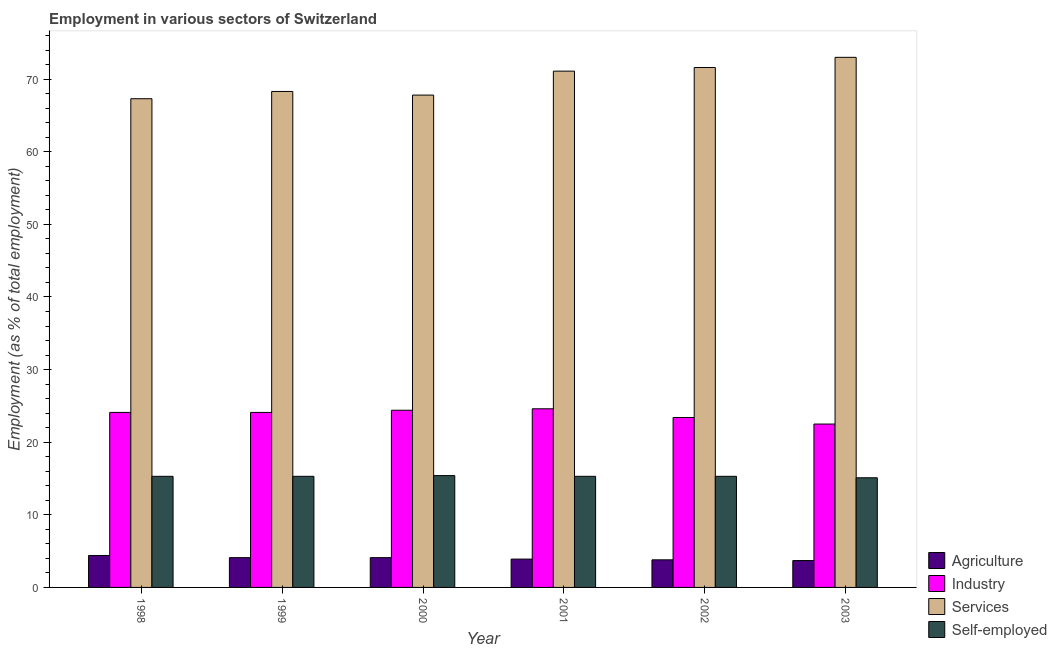How many groups of bars are there?
Your response must be concise. 6. Are the number of bars per tick equal to the number of legend labels?
Offer a very short reply. Yes. How many bars are there on the 1st tick from the left?
Ensure brevity in your answer.  4. How many bars are there on the 3rd tick from the right?
Offer a terse response. 4. What is the label of the 6th group of bars from the left?
Your answer should be compact. 2003. What is the percentage of workers in industry in 2001?
Your answer should be compact. 24.6. Across all years, what is the minimum percentage of self employed workers?
Your answer should be very brief. 15.1. In which year was the percentage of self employed workers maximum?
Your answer should be very brief. 2000. What is the total percentage of self employed workers in the graph?
Provide a succinct answer. 91.7. What is the difference between the percentage of workers in services in 2001 and that in 2003?
Offer a very short reply. -1.9. What is the difference between the percentage of workers in industry in 2003 and the percentage of workers in services in 1999?
Your answer should be compact. -1.6. What is the average percentage of workers in services per year?
Make the answer very short. 69.85. In the year 2002, what is the difference between the percentage of workers in agriculture and percentage of workers in services?
Make the answer very short. 0. Is the percentage of workers in industry in 2001 less than that in 2002?
Keep it short and to the point. No. Is the difference between the percentage of self employed workers in 2002 and 2003 greater than the difference between the percentage of workers in services in 2002 and 2003?
Your response must be concise. No. What is the difference between the highest and the second highest percentage of workers in industry?
Your answer should be very brief. 0.2. What is the difference between the highest and the lowest percentage of workers in agriculture?
Make the answer very short. 0.7. In how many years, is the percentage of workers in services greater than the average percentage of workers in services taken over all years?
Your answer should be very brief. 3. Is it the case that in every year, the sum of the percentage of self employed workers and percentage of workers in services is greater than the sum of percentage of workers in industry and percentage of workers in agriculture?
Make the answer very short. No. What does the 4th bar from the left in 2000 represents?
Your answer should be compact. Self-employed. What does the 2nd bar from the right in 2000 represents?
Offer a very short reply. Services. Is it the case that in every year, the sum of the percentage of workers in agriculture and percentage of workers in industry is greater than the percentage of workers in services?
Your answer should be very brief. No. How many years are there in the graph?
Make the answer very short. 6. What is the difference between two consecutive major ticks on the Y-axis?
Provide a short and direct response. 10. Where does the legend appear in the graph?
Provide a succinct answer. Bottom right. How many legend labels are there?
Offer a very short reply. 4. What is the title of the graph?
Keep it short and to the point. Employment in various sectors of Switzerland. Does "Social equity" appear as one of the legend labels in the graph?
Make the answer very short. No. What is the label or title of the X-axis?
Ensure brevity in your answer.  Year. What is the label or title of the Y-axis?
Your response must be concise. Employment (as % of total employment). What is the Employment (as % of total employment) in Agriculture in 1998?
Your response must be concise. 4.4. What is the Employment (as % of total employment) in Industry in 1998?
Keep it short and to the point. 24.1. What is the Employment (as % of total employment) in Services in 1998?
Provide a succinct answer. 67.3. What is the Employment (as % of total employment) of Self-employed in 1998?
Your answer should be compact. 15.3. What is the Employment (as % of total employment) in Agriculture in 1999?
Your answer should be very brief. 4.1. What is the Employment (as % of total employment) of Industry in 1999?
Give a very brief answer. 24.1. What is the Employment (as % of total employment) of Services in 1999?
Keep it short and to the point. 68.3. What is the Employment (as % of total employment) in Self-employed in 1999?
Keep it short and to the point. 15.3. What is the Employment (as % of total employment) of Agriculture in 2000?
Your answer should be compact. 4.1. What is the Employment (as % of total employment) of Industry in 2000?
Give a very brief answer. 24.4. What is the Employment (as % of total employment) in Services in 2000?
Offer a very short reply. 67.8. What is the Employment (as % of total employment) in Self-employed in 2000?
Ensure brevity in your answer.  15.4. What is the Employment (as % of total employment) in Agriculture in 2001?
Provide a succinct answer. 3.9. What is the Employment (as % of total employment) in Industry in 2001?
Make the answer very short. 24.6. What is the Employment (as % of total employment) of Services in 2001?
Provide a succinct answer. 71.1. What is the Employment (as % of total employment) in Self-employed in 2001?
Provide a succinct answer. 15.3. What is the Employment (as % of total employment) in Agriculture in 2002?
Offer a terse response. 3.8. What is the Employment (as % of total employment) of Industry in 2002?
Offer a very short reply. 23.4. What is the Employment (as % of total employment) in Services in 2002?
Your answer should be compact. 71.6. What is the Employment (as % of total employment) in Self-employed in 2002?
Your answer should be very brief. 15.3. What is the Employment (as % of total employment) of Agriculture in 2003?
Offer a very short reply. 3.7. What is the Employment (as % of total employment) in Services in 2003?
Offer a very short reply. 73. What is the Employment (as % of total employment) of Self-employed in 2003?
Provide a short and direct response. 15.1. Across all years, what is the maximum Employment (as % of total employment) of Agriculture?
Make the answer very short. 4.4. Across all years, what is the maximum Employment (as % of total employment) in Industry?
Provide a short and direct response. 24.6. Across all years, what is the maximum Employment (as % of total employment) in Self-employed?
Your response must be concise. 15.4. Across all years, what is the minimum Employment (as % of total employment) in Agriculture?
Offer a very short reply. 3.7. Across all years, what is the minimum Employment (as % of total employment) of Services?
Provide a succinct answer. 67.3. Across all years, what is the minimum Employment (as % of total employment) of Self-employed?
Your answer should be compact. 15.1. What is the total Employment (as % of total employment) of Agriculture in the graph?
Give a very brief answer. 24. What is the total Employment (as % of total employment) in Industry in the graph?
Your answer should be very brief. 143.1. What is the total Employment (as % of total employment) of Services in the graph?
Your answer should be compact. 419.1. What is the total Employment (as % of total employment) of Self-employed in the graph?
Provide a short and direct response. 91.7. What is the difference between the Employment (as % of total employment) of Industry in 1998 and that in 1999?
Ensure brevity in your answer.  0. What is the difference between the Employment (as % of total employment) of Services in 1998 and that in 1999?
Your answer should be compact. -1. What is the difference between the Employment (as % of total employment) of Self-employed in 1998 and that in 1999?
Your answer should be very brief. 0. What is the difference between the Employment (as % of total employment) in Services in 1998 and that in 2000?
Ensure brevity in your answer.  -0.5. What is the difference between the Employment (as % of total employment) of Agriculture in 1998 and that in 2001?
Your answer should be compact. 0.5. What is the difference between the Employment (as % of total employment) in Industry in 1998 and that in 2001?
Provide a succinct answer. -0.5. What is the difference between the Employment (as % of total employment) in Services in 1998 and that in 2001?
Your answer should be compact. -3.8. What is the difference between the Employment (as % of total employment) of Agriculture in 1998 and that in 2002?
Provide a short and direct response. 0.6. What is the difference between the Employment (as % of total employment) of Agriculture in 1998 and that in 2003?
Keep it short and to the point. 0.7. What is the difference between the Employment (as % of total employment) in Services in 1998 and that in 2003?
Offer a terse response. -5.7. What is the difference between the Employment (as % of total employment) of Self-employed in 1998 and that in 2003?
Your answer should be compact. 0.2. What is the difference between the Employment (as % of total employment) of Industry in 1999 and that in 2000?
Ensure brevity in your answer.  -0.3. What is the difference between the Employment (as % of total employment) in Services in 1999 and that in 2000?
Offer a terse response. 0.5. What is the difference between the Employment (as % of total employment) in Self-employed in 1999 and that in 2000?
Provide a succinct answer. -0.1. What is the difference between the Employment (as % of total employment) in Agriculture in 1999 and that in 2001?
Provide a succinct answer. 0.2. What is the difference between the Employment (as % of total employment) in Services in 1999 and that in 2001?
Offer a very short reply. -2.8. What is the difference between the Employment (as % of total employment) of Industry in 1999 and that in 2003?
Offer a very short reply. 1.6. What is the difference between the Employment (as % of total employment) in Services in 1999 and that in 2003?
Provide a succinct answer. -4.7. What is the difference between the Employment (as % of total employment) in Services in 2000 and that in 2001?
Keep it short and to the point. -3.3. What is the difference between the Employment (as % of total employment) in Agriculture in 2000 and that in 2002?
Offer a terse response. 0.3. What is the difference between the Employment (as % of total employment) of Self-employed in 2000 and that in 2002?
Your answer should be compact. 0.1. What is the difference between the Employment (as % of total employment) in Agriculture in 2000 and that in 2003?
Provide a short and direct response. 0.4. What is the difference between the Employment (as % of total employment) of Industry in 2000 and that in 2003?
Ensure brevity in your answer.  1.9. What is the difference between the Employment (as % of total employment) of Services in 2000 and that in 2003?
Your answer should be compact. -5.2. What is the difference between the Employment (as % of total employment) in Services in 2001 and that in 2002?
Give a very brief answer. -0.5. What is the difference between the Employment (as % of total employment) in Agriculture in 2001 and that in 2003?
Provide a succinct answer. 0.2. What is the difference between the Employment (as % of total employment) of Industry in 2001 and that in 2003?
Your answer should be compact. 2.1. What is the difference between the Employment (as % of total employment) of Services in 2001 and that in 2003?
Provide a succinct answer. -1.9. What is the difference between the Employment (as % of total employment) of Self-employed in 2001 and that in 2003?
Keep it short and to the point. 0.2. What is the difference between the Employment (as % of total employment) in Agriculture in 2002 and that in 2003?
Ensure brevity in your answer.  0.1. What is the difference between the Employment (as % of total employment) of Industry in 2002 and that in 2003?
Provide a short and direct response. 0.9. What is the difference between the Employment (as % of total employment) in Services in 2002 and that in 2003?
Keep it short and to the point. -1.4. What is the difference between the Employment (as % of total employment) in Self-employed in 2002 and that in 2003?
Offer a terse response. 0.2. What is the difference between the Employment (as % of total employment) of Agriculture in 1998 and the Employment (as % of total employment) of Industry in 1999?
Offer a very short reply. -19.7. What is the difference between the Employment (as % of total employment) in Agriculture in 1998 and the Employment (as % of total employment) in Services in 1999?
Provide a succinct answer. -63.9. What is the difference between the Employment (as % of total employment) in Agriculture in 1998 and the Employment (as % of total employment) in Self-employed in 1999?
Provide a succinct answer. -10.9. What is the difference between the Employment (as % of total employment) in Industry in 1998 and the Employment (as % of total employment) in Services in 1999?
Your response must be concise. -44.2. What is the difference between the Employment (as % of total employment) of Industry in 1998 and the Employment (as % of total employment) of Self-employed in 1999?
Your answer should be compact. 8.8. What is the difference between the Employment (as % of total employment) of Agriculture in 1998 and the Employment (as % of total employment) of Services in 2000?
Offer a terse response. -63.4. What is the difference between the Employment (as % of total employment) of Agriculture in 1998 and the Employment (as % of total employment) of Self-employed in 2000?
Provide a succinct answer. -11. What is the difference between the Employment (as % of total employment) in Industry in 1998 and the Employment (as % of total employment) in Services in 2000?
Provide a short and direct response. -43.7. What is the difference between the Employment (as % of total employment) in Industry in 1998 and the Employment (as % of total employment) in Self-employed in 2000?
Make the answer very short. 8.7. What is the difference between the Employment (as % of total employment) in Services in 1998 and the Employment (as % of total employment) in Self-employed in 2000?
Provide a short and direct response. 51.9. What is the difference between the Employment (as % of total employment) in Agriculture in 1998 and the Employment (as % of total employment) in Industry in 2001?
Provide a succinct answer. -20.2. What is the difference between the Employment (as % of total employment) in Agriculture in 1998 and the Employment (as % of total employment) in Services in 2001?
Provide a short and direct response. -66.7. What is the difference between the Employment (as % of total employment) in Industry in 1998 and the Employment (as % of total employment) in Services in 2001?
Offer a terse response. -47. What is the difference between the Employment (as % of total employment) of Industry in 1998 and the Employment (as % of total employment) of Self-employed in 2001?
Your answer should be very brief. 8.8. What is the difference between the Employment (as % of total employment) in Services in 1998 and the Employment (as % of total employment) in Self-employed in 2001?
Give a very brief answer. 52. What is the difference between the Employment (as % of total employment) of Agriculture in 1998 and the Employment (as % of total employment) of Industry in 2002?
Ensure brevity in your answer.  -19. What is the difference between the Employment (as % of total employment) in Agriculture in 1998 and the Employment (as % of total employment) in Services in 2002?
Offer a very short reply. -67.2. What is the difference between the Employment (as % of total employment) of Agriculture in 1998 and the Employment (as % of total employment) of Self-employed in 2002?
Offer a terse response. -10.9. What is the difference between the Employment (as % of total employment) in Industry in 1998 and the Employment (as % of total employment) in Services in 2002?
Provide a short and direct response. -47.5. What is the difference between the Employment (as % of total employment) in Agriculture in 1998 and the Employment (as % of total employment) in Industry in 2003?
Give a very brief answer. -18.1. What is the difference between the Employment (as % of total employment) of Agriculture in 1998 and the Employment (as % of total employment) of Services in 2003?
Offer a terse response. -68.6. What is the difference between the Employment (as % of total employment) of Agriculture in 1998 and the Employment (as % of total employment) of Self-employed in 2003?
Keep it short and to the point. -10.7. What is the difference between the Employment (as % of total employment) in Industry in 1998 and the Employment (as % of total employment) in Services in 2003?
Ensure brevity in your answer.  -48.9. What is the difference between the Employment (as % of total employment) of Services in 1998 and the Employment (as % of total employment) of Self-employed in 2003?
Provide a short and direct response. 52.2. What is the difference between the Employment (as % of total employment) in Agriculture in 1999 and the Employment (as % of total employment) in Industry in 2000?
Provide a succinct answer. -20.3. What is the difference between the Employment (as % of total employment) in Agriculture in 1999 and the Employment (as % of total employment) in Services in 2000?
Give a very brief answer. -63.7. What is the difference between the Employment (as % of total employment) of Industry in 1999 and the Employment (as % of total employment) of Services in 2000?
Keep it short and to the point. -43.7. What is the difference between the Employment (as % of total employment) of Services in 1999 and the Employment (as % of total employment) of Self-employed in 2000?
Your answer should be very brief. 52.9. What is the difference between the Employment (as % of total employment) of Agriculture in 1999 and the Employment (as % of total employment) of Industry in 2001?
Your response must be concise. -20.5. What is the difference between the Employment (as % of total employment) in Agriculture in 1999 and the Employment (as % of total employment) in Services in 2001?
Offer a very short reply. -67. What is the difference between the Employment (as % of total employment) of Industry in 1999 and the Employment (as % of total employment) of Services in 2001?
Ensure brevity in your answer.  -47. What is the difference between the Employment (as % of total employment) in Services in 1999 and the Employment (as % of total employment) in Self-employed in 2001?
Your answer should be very brief. 53. What is the difference between the Employment (as % of total employment) in Agriculture in 1999 and the Employment (as % of total employment) in Industry in 2002?
Offer a terse response. -19.3. What is the difference between the Employment (as % of total employment) of Agriculture in 1999 and the Employment (as % of total employment) of Services in 2002?
Make the answer very short. -67.5. What is the difference between the Employment (as % of total employment) in Agriculture in 1999 and the Employment (as % of total employment) in Self-employed in 2002?
Offer a very short reply. -11.2. What is the difference between the Employment (as % of total employment) of Industry in 1999 and the Employment (as % of total employment) of Services in 2002?
Provide a short and direct response. -47.5. What is the difference between the Employment (as % of total employment) of Industry in 1999 and the Employment (as % of total employment) of Self-employed in 2002?
Give a very brief answer. 8.8. What is the difference between the Employment (as % of total employment) in Agriculture in 1999 and the Employment (as % of total employment) in Industry in 2003?
Your response must be concise. -18.4. What is the difference between the Employment (as % of total employment) of Agriculture in 1999 and the Employment (as % of total employment) of Services in 2003?
Provide a short and direct response. -68.9. What is the difference between the Employment (as % of total employment) of Agriculture in 1999 and the Employment (as % of total employment) of Self-employed in 2003?
Offer a terse response. -11. What is the difference between the Employment (as % of total employment) in Industry in 1999 and the Employment (as % of total employment) in Services in 2003?
Give a very brief answer. -48.9. What is the difference between the Employment (as % of total employment) of Services in 1999 and the Employment (as % of total employment) of Self-employed in 2003?
Keep it short and to the point. 53.2. What is the difference between the Employment (as % of total employment) in Agriculture in 2000 and the Employment (as % of total employment) in Industry in 2001?
Your answer should be compact. -20.5. What is the difference between the Employment (as % of total employment) of Agriculture in 2000 and the Employment (as % of total employment) of Services in 2001?
Keep it short and to the point. -67. What is the difference between the Employment (as % of total employment) of Agriculture in 2000 and the Employment (as % of total employment) of Self-employed in 2001?
Provide a succinct answer. -11.2. What is the difference between the Employment (as % of total employment) of Industry in 2000 and the Employment (as % of total employment) of Services in 2001?
Make the answer very short. -46.7. What is the difference between the Employment (as % of total employment) in Industry in 2000 and the Employment (as % of total employment) in Self-employed in 2001?
Offer a very short reply. 9.1. What is the difference between the Employment (as % of total employment) in Services in 2000 and the Employment (as % of total employment) in Self-employed in 2001?
Your answer should be very brief. 52.5. What is the difference between the Employment (as % of total employment) in Agriculture in 2000 and the Employment (as % of total employment) in Industry in 2002?
Keep it short and to the point. -19.3. What is the difference between the Employment (as % of total employment) in Agriculture in 2000 and the Employment (as % of total employment) in Services in 2002?
Give a very brief answer. -67.5. What is the difference between the Employment (as % of total employment) in Agriculture in 2000 and the Employment (as % of total employment) in Self-employed in 2002?
Offer a very short reply. -11.2. What is the difference between the Employment (as % of total employment) of Industry in 2000 and the Employment (as % of total employment) of Services in 2002?
Provide a short and direct response. -47.2. What is the difference between the Employment (as % of total employment) of Services in 2000 and the Employment (as % of total employment) of Self-employed in 2002?
Make the answer very short. 52.5. What is the difference between the Employment (as % of total employment) of Agriculture in 2000 and the Employment (as % of total employment) of Industry in 2003?
Provide a short and direct response. -18.4. What is the difference between the Employment (as % of total employment) of Agriculture in 2000 and the Employment (as % of total employment) of Services in 2003?
Your answer should be very brief. -68.9. What is the difference between the Employment (as % of total employment) in Industry in 2000 and the Employment (as % of total employment) in Services in 2003?
Your answer should be compact. -48.6. What is the difference between the Employment (as % of total employment) in Services in 2000 and the Employment (as % of total employment) in Self-employed in 2003?
Offer a very short reply. 52.7. What is the difference between the Employment (as % of total employment) of Agriculture in 2001 and the Employment (as % of total employment) of Industry in 2002?
Offer a terse response. -19.5. What is the difference between the Employment (as % of total employment) in Agriculture in 2001 and the Employment (as % of total employment) in Services in 2002?
Make the answer very short. -67.7. What is the difference between the Employment (as % of total employment) of Industry in 2001 and the Employment (as % of total employment) of Services in 2002?
Ensure brevity in your answer.  -47. What is the difference between the Employment (as % of total employment) in Services in 2001 and the Employment (as % of total employment) in Self-employed in 2002?
Make the answer very short. 55.8. What is the difference between the Employment (as % of total employment) of Agriculture in 2001 and the Employment (as % of total employment) of Industry in 2003?
Your answer should be very brief. -18.6. What is the difference between the Employment (as % of total employment) of Agriculture in 2001 and the Employment (as % of total employment) of Services in 2003?
Provide a succinct answer. -69.1. What is the difference between the Employment (as % of total employment) in Agriculture in 2001 and the Employment (as % of total employment) in Self-employed in 2003?
Give a very brief answer. -11.2. What is the difference between the Employment (as % of total employment) in Industry in 2001 and the Employment (as % of total employment) in Services in 2003?
Your answer should be compact. -48.4. What is the difference between the Employment (as % of total employment) in Services in 2001 and the Employment (as % of total employment) in Self-employed in 2003?
Provide a succinct answer. 56. What is the difference between the Employment (as % of total employment) of Agriculture in 2002 and the Employment (as % of total employment) of Industry in 2003?
Ensure brevity in your answer.  -18.7. What is the difference between the Employment (as % of total employment) in Agriculture in 2002 and the Employment (as % of total employment) in Services in 2003?
Offer a terse response. -69.2. What is the difference between the Employment (as % of total employment) of Industry in 2002 and the Employment (as % of total employment) of Services in 2003?
Offer a very short reply. -49.6. What is the difference between the Employment (as % of total employment) in Services in 2002 and the Employment (as % of total employment) in Self-employed in 2003?
Provide a short and direct response. 56.5. What is the average Employment (as % of total employment) in Agriculture per year?
Keep it short and to the point. 4. What is the average Employment (as % of total employment) of Industry per year?
Your response must be concise. 23.85. What is the average Employment (as % of total employment) in Services per year?
Ensure brevity in your answer.  69.85. What is the average Employment (as % of total employment) in Self-employed per year?
Make the answer very short. 15.28. In the year 1998, what is the difference between the Employment (as % of total employment) in Agriculture and Employment (as % of total employment) in Industry?
Your answer should be compact. -19.7. In the year 1998, what is the difference between the Employment (as % of total employment) of Agriculture and Employment (as % of total employment) of Services?
Your answer should be compact. -62.9. In the year 1998, what is the difference between the Employment (as % of total employment) in Industry and Employment (as % of total employment) in Services?
Provide a short and direct response. -43.2. In the year 1998, what is the difference between the Employment (as % of total employment) in Services and Employment (as % of total employment) in Self-employed?
Provide a succinct answer. 52. In the year 1999, what is the difference between the Employment (as % of total employment) of Agriculture and Employment (as % of total employment) of Services?
Your response must be concise. -64.2. In the year 1999, what is the difference between the Employment (as % of total employment) in Agriculture and Employment (as % of total employment) in Self-employed?
Ensure brevity in your answer.  -11.2. In the year 1999, what is the difference between the Employment (as % of total employment) in Industry and Employment (as % of total employment) in Services?
Provide a short and direct response. -44.2. In the year 1999, what is the difference between the Employment (as % of total employment) of Services and Employment (as % of total employment) of Self-employed?
Make the answer very short. 53. In the year 2000, what is the difference between the Employment (as % of total employment) in Agriculture and Employment (as % of total employment) in Industry?
Provide a succinct answer. -20.3. In the year 2000, what is the difference between the Employment (as % of total employment) in Agriculture and Employment (as % of total employment) in Services?
Provide a succinct answer. -63.7. In the year 2000, what is the difference between the Employment (as % of total employment) of Industry and Employment (as % of total employment) of Services?
Provide a short and direct response. -43.4. In the year 2000, what is the difference between the Employment (as % of total employment) in Services and Employment (as % of total employment) in Self-employed?
Your response must be concise. 52.4. In the year 2001, what is the difference between the Employment (as % of total employment) of Agriculture and Employment (as % of total employment) of Industry?
Ensure brevity in your answer.  -20.7. In the year 2001, what is the difference between the Employment (as % of total employment) in Agriculture and Employment (as % of total employment) in Services?
Provide a short and direct response. -67.2. In the year 2001, what is the difference between the Employment (as % of total employment) in Industry and Employment (as % of total employment) in Services?
Your response must be concise. -46.5. In the year 2001, what is the difference between the Employment (as % of total employment) in Industry and Employment (as % of total employment) in Self-employed?
Your answer should be very brief. 9.3. In the year 2001, what is the difference between the Employment (as % of total employment) of Services and Employment (as % of total employment) of Self-employed?
Keep it short and to the point. 55.8. In the year 2002, what is the difference between the Employment (as % of total employment) of Agriculture and Employment (as % of total employment) of Industry?
Give a very brief answer. -19.6. In the year 2002, what is the difference between the Employment (as % of total employment) in Agriculture and Employment (as % of total employment) in Services?
Make the answer very short. -67.8. In the year 2002, what is the difference between the Employment (as % of total employment) of Agriculture and Employment (as % of total employment) of Self-employed?
Ensure brevity in your answer.  -11.5. In the year 2002, what is the difference between the Employment (as % of total employment) of Industry and Employment (as % of total employment) of Services?
Provide a succinct answer. -48.2. In the year 2002, what is the difference between the Employment (as % of total employment) in Services and Employment (as % of total employment) in Self-employed?
Your response must be concise. 56.3. In the year 2003, what is the difference between the Employment (as % of total employment) of Agriculture and Employment (as % of total employment) of Industry?
Offer a terse response. -18.8. In the year 2003, what is the difference between the Employment (as % of total employment) of Agriculture and Employment (as % of total employment) of Services?
Offer a very short reply. -69.3. In the year 2003, what is the difference between the Employment (as % of total employment) of Industry and Employment (as % of total employment) of Services?
Your answer should be very brief. -50.5. In the year 2003, what is the difference between the Employment (as % of total employment) in Industry and Employment (as % of total employment) in Self-employed?
Your answer should be very brief. 7.4. In the year 2003, what is the difference between the Employment (as % of total employment) in Services and Employment (as % of total employment) in Self-employed?
Provide a succinct answer. 57.9. What is the ratio of the Employment (as % of total employment) in Agriculture in 1998 to that in 1999?
Offer a terse response. 1.07. What is the ratio of the Employment (as % of total employment) in Services in 1998 to that in 1999?
Provide a succinct answer. 0.99. What is the ratio of the Employment (as % of total employment) in Agriculture in 1998 to that in 2000?
Make the answer very short. 1.07. What is the ratio of the Employment (as % of total employment) of Industry in 1998 to that in 2000?
Provide a succinct answer. 0.99. What is the ratio of the Employment (as % of total employment) of Services in 1998 to that in 2000?
Offer a terse response. 0.99. What is the ratio of the Employment (as % of total employment) of Agriculture in 1998 to that in 2001?
Offer a very short reply. 1.13. What is the ratio of the Employment (as % of total employment) of Industry in 1998 to that in 2001?
Your answer should be very brief. 0.98. What is the ratio of the Employment (as % of total employment) of Services in 1998 to that in 2001?
Your answer should be compact. 0.95. What is the ratio of the Employment (as % of total employment) in Agriculture in 1998 to that in 2002?
Keep it short and to the point. 1.16. What is the ratio of the Employment (as % of total employment) in Industry in 1998 to that in 2002?
Your answer should be very brief. 1.03. What is the ratio of the Employment (as % of total employment) of Services in 1998 to that in 2002?
Ensure brevity in your answer.  0.94. What is the ratio of the Employment (as % of total employment) of Self-employed in 1998 to that in 2002?
Provide a succinct answer. 1. What is the ratio of the Employment (as % of total employment) in Agriculture in 1998 to that in 2003?
Offer a very short reply. 1.19. What is the ratio of the Employment (as % of total employment) of Industry in 1998 to that in 2003?
Your answer should be very brief. 1.07. What is the ratio of the Employment (as % of total employment) in Services in 1998 to that in 2003?
Your answer should be compact. 0.92. What is the ratio of the Employment (as % of total employment) in Self-employed in 1998 to that in 2003?
Ensure brevity in your answer.  1.01. What is the ratio of the Employment (as % of total employment) of Agriculture in 1999 to that in 2000?
Your answer should be compact. 1. What is the ratio of the Employment (as % of total employment) in Industry in 1999 to that in 2000?
Keep it short and to the point. 0.99. What is the ratio of the Employment (as % of total employment) of Services in 1999 to that in 2000?
Provide a succinct answer. 1.01. What is the ratio of the Employment (as % of total employment) of Self-employed in 1999 to that in 2000?
Your response must be concise. 0.99. What is the ratio of the Employment (as % of total employment) in Agriculture in 1999 to that in 2001?
Offer a very short reply. 1.05. What is the ratio of the Employment (as % of total employment) of Industry in 1999 to that in 2001?
Offer a very short reply. 0.98. What is the ratio of the Employment (as % of total employment) in Services in 1999 to that in 2001?
Give a very brief answer. 0.96. What is the ratio of the Employment (as % of total employment) in Self-employed in 1999 to that in 2001?
Offer a terse response. 1. What is the ratio of the Employment (as % of total employment) of Agriculture in 1999 to that in 2002?
Your response must be concise. 1.08. What is the ratio of the Employment (as % of total employment) of Industry in 1999 to that in 2002?
Make the answer very short. 1.03. What is the ratio of the Employment (as % of total employment) of Services in 1999 to that in 2002?
Make the answer very short. 0.95. What is the ratio of the Employment (as % of total employment) of Agriculture in 1999 to that in 2003?
Your answer should be compact. 1.11. What is the ratio of the Employment (as % of total employment) in Industry in 1999 to that in 2003?
Offer a very short reply. 1.07. What is the ratio of the Employment (as % of total employment) in Services in 1999 to that in 2003?
Provide a short and direct response. 0.94. What is the ratio of the Employment (as % of total employment) in Self-employed in 1999 to that in 2003?
Provide a short and direct response. 1.01. What is the ratio of the Employment (as % of total employment) in Agriculture in 2000 to that in 2001?
Make the answer very short. 1.05. What is the ratio of the Employment (as % of total employment) in Services in 2000 to that in 2001?
Ensure brevity in your answer.  0.95. What is the ratio of the Employment (as % of total employment) of Self-employed in 2000 to that in 2001?
Your answer should be compact. 1.01. What is the ratio of the Employment (as % of total employment) of Agriculture in 2000 to that in 2002?
Your response must be concise. 1.08. What is the ratio of the Employment (as % of total employment) of Industry in 2000 to that in 2002?
Provide a short and direct response. 1.04. What is the ratio of the Employment (as % of total employment) of Services in 2000 to that in 2002?
Your response must be concise. 0.95. What is the ratio of the Employment (as % of total employment) of Self-employed in 2000 to that in 2002?
Your answer should be compact. 1.01. What is the ratio of the Employment (as % of total employment) of Agriculture in 2000 to that in 2003?
Ensure brevity in your answer.  1.11. What is the ratio of the Employment (as % of total employment) in Industry in 2000 to that in 2003?
Offer a terse response. 1.08. What is the ratio of the Employment (as % of total employment) in Services in 2000 to that in 2003?
Provide a short and direct response. 0.93. What is the ratio of the Employment (as % of total employment) of Self-employed in 2000 to that in 2003?
Provide a short and direct response. 1.02. What is the ratio of the Employment (as % of total employment) in Agriculture in 2001 to that in 2002?
Offer a very short reply. 1.03. What is the ratio of the Employment (as % of total employment) in Industry in 2001 to that in 2002?
Your answer should be very brief. 1.05. What is the ratio of the Employment (as % of total employment) in Self-employed in 2001 to that in 2002?
Provide a succinct answer. 1. What is the ratio of the Employment (as % of total employment) of Agriculture in 2001 to that in 2003?
Offer a very short reply. 1.05. What is the ratio of the Employment (as % of total employment) of Industry in 2001 to that in 2003?
Make the answer very short. 1.09. What is the ratio of the Employment (as % of total employment) in Services in 2001 to that in 2003?
Your answer should be very brief. 0.97. What is the ratio of the Employment (as % of total employment) of Self-employed in 2001 to that in 2003?
Make the answer very short. 1.01. What is the ratio of the Employment (as % of total employment) of Industry in 2002 to that in 2003?
Your answer should be very brief. 1.04. What is the ratio of the Employment (as % of total employment) of Services in 2002 to that in 2003?
Your answer should be compact. 0.98. What is the ratio of the Employment (as % of total employment) of Self-employed in 2002 to that in 2003?
Give a very brief answer. 1.01. What is the difference between the highest and the second highest Employment (as % of total employment) of Agriculture?
Give a very brief answer. 0.3. What is the difference between the highest and the second highest Employment (as % of total employment) in Industry?
Give a very brief answer. 0.2. What is the difference between the highest and the lowest Employment (as % of total employment) in Services?
Keep it short and to the point. 5.7. 